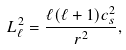Convert formula to latex. <formula><loc_0><loc_0><loc_500><loc_500>L ^ { 2 } _ { \ell } = \frac { \ell ( \ell + 1 ) c _ { s } ^ { 2 } } { r ^ { 2 } } ,</formula> 